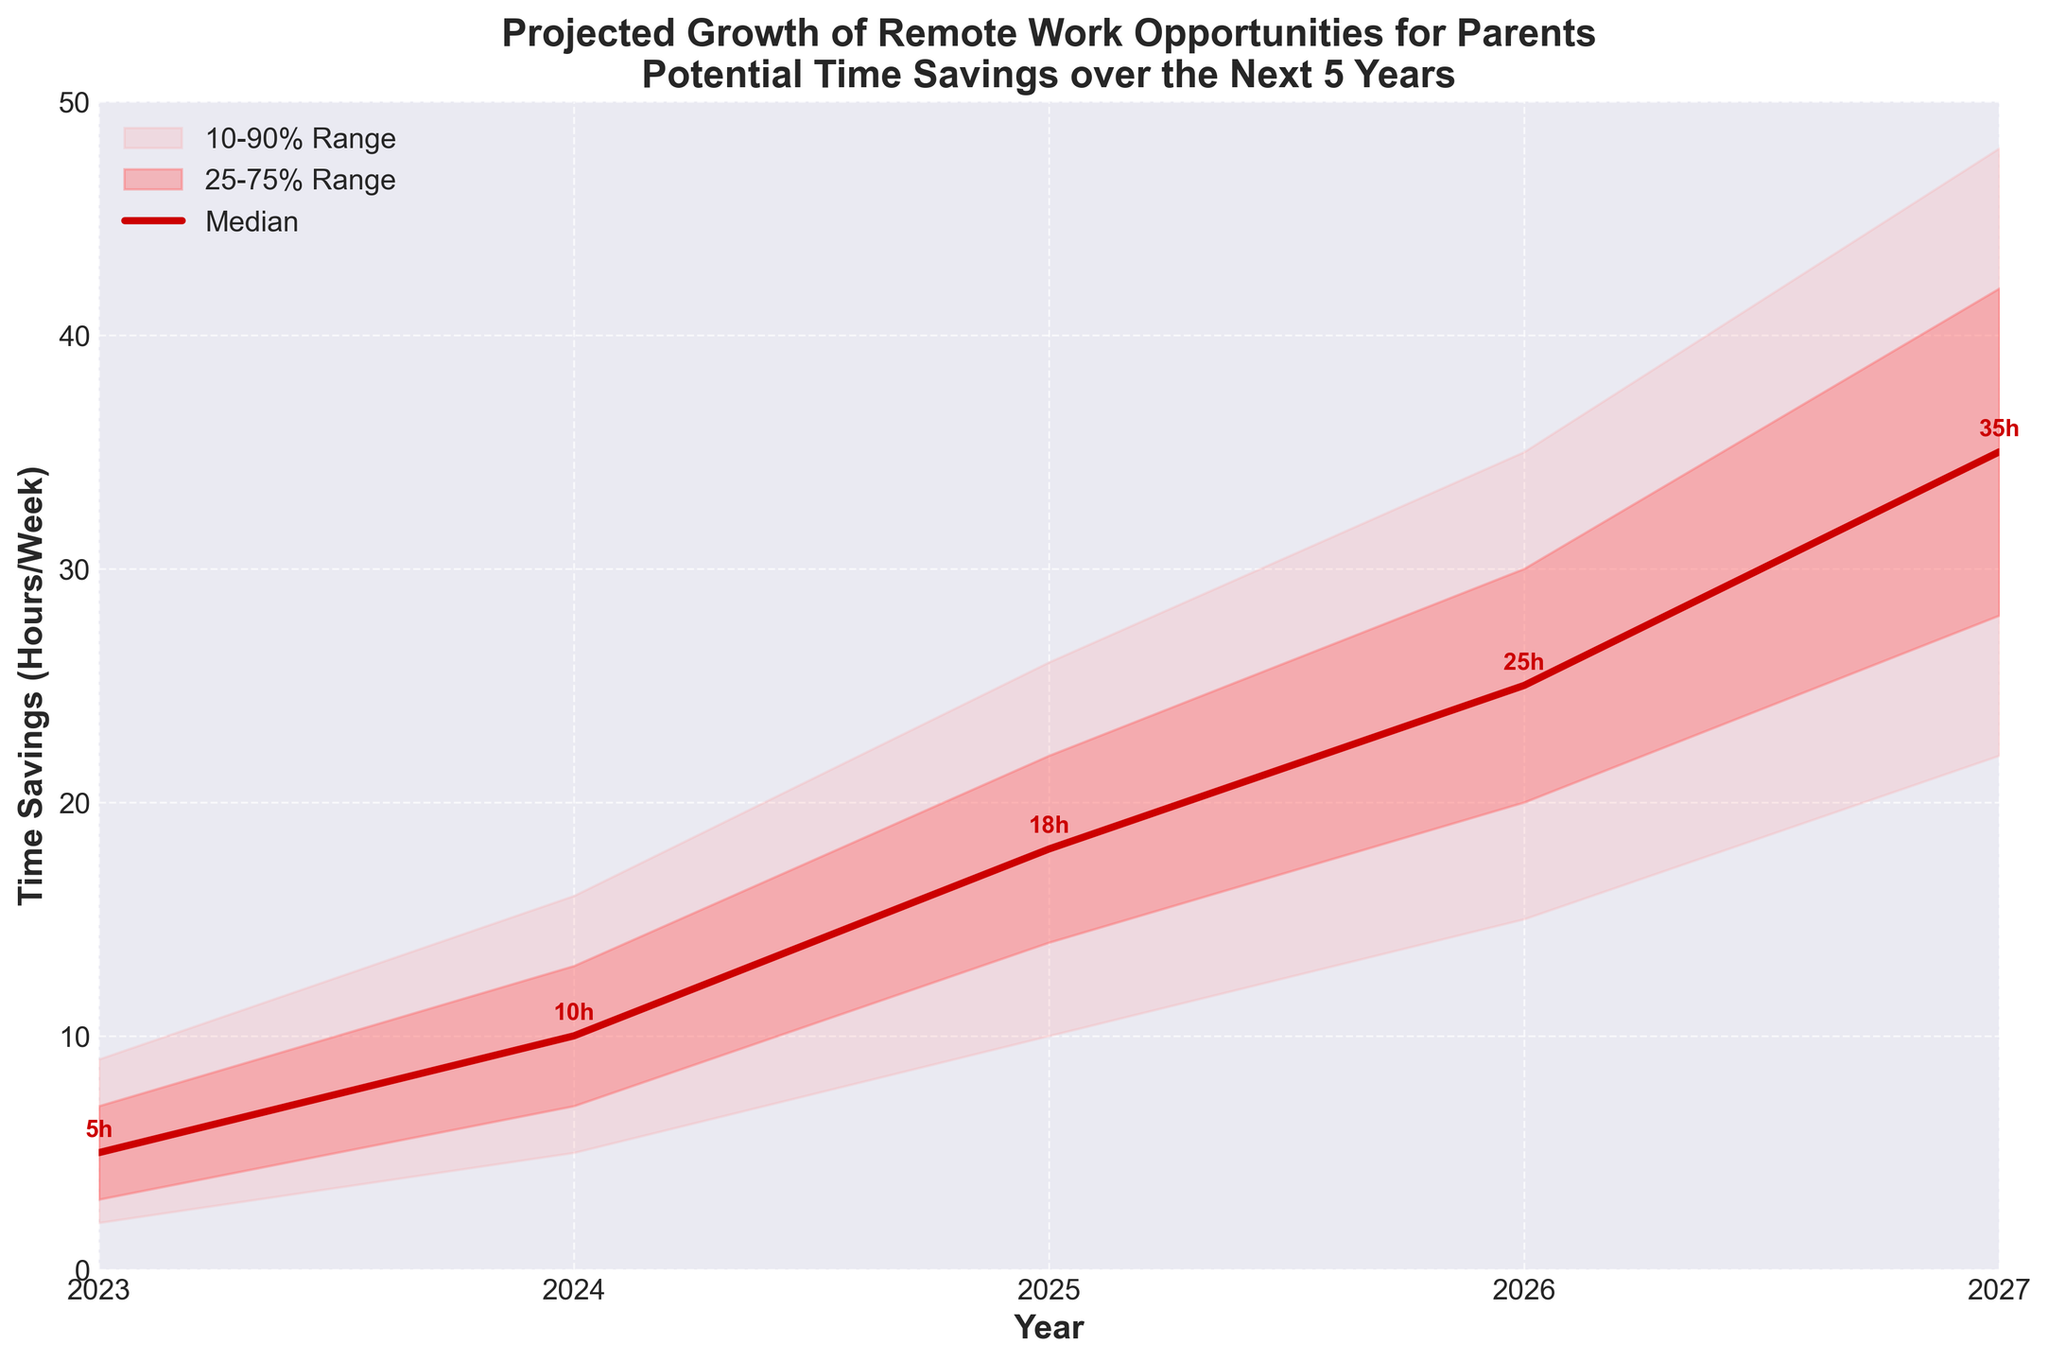what is the title of the figure? The title of the figure is located at the top. It reads: "Projected Growth of Remote Work Opportunities for Parents: Potential Time Savings over the Next 5 Years".
Answer: Projected Growth of Remote Work Opportunities for Parents: Potential Time Savings over the Next 5 Years How many years are shown in the plot? The x-axis labels the years, and they range from 2023 to 2027. Counting them, there are five years in total.
Answer: 5 What is the median projected time savings for the year 2025? The median values for each year are marked and labeled along the central line of the plot. For 2025, the median value labeled is 18 hours.
Answer: 18 hours By how many hours is the lower 10% value in 2027 different from the lower 25% value in the same year? The lower 10% value for 2027 is 22 hours, and the lower 25% value is 28 hours. The difference is calculated as 28 - 22 hours.
Answer: 6 hours What is the difference between the upper 90% and the lower 10% time savings for the year 2024? Looking at the values on the y-axis for 2024, the upper 90% is 16 hours and the lower 10% is 5 hours. The difference is calculated as 16 - 5 hours.
Answer: 11 hours Which year shows the highest median time savings, and what is this value? Among the labeled median values, the highest is for the year 2027 with a value of 35 hours.
Answer: 2027, 35 hours What is the range of potential time savings (10%-90%) in 2026? For 2026, the plot shows the lower 10% value as 15 hours and the upper 90% value as 35 hours. The range is calculated as 35 - 15 hours.
Answer: 20 hours Between which two consecutive years is the increase in median time savings the greatest? By examining the median values for consecutive years:
  - 2023 to 2024: 10 - 5 = 5 hours
  - 2024 to 2025: 18 - 10 = 8 hours
  - 2025 to 2026: 25 - 18 = 7 hours
  - 2026 to 2027: 35 - 25 = 10 hours
The greatest increase is between 2026 and 2027.
Answer: 2026 to 2027 Which range (lower 10%-upper 90% or lower 25%-upper 75%) shows a wider spread for 2024? For 2024, the 10%-90% range is from 5 to 16 hours, so 16 - 5 = 11 hours. The 25%-75% range is from 7 to 13 hours, so 13 - 7 = 6 hours. The 10%-90% range is wider.
Answer: 10%-90% How does the spread of potential savings in 2027 (10%-90%) compare to that in 2023? For 2023, the spread is 9 - 2 = 7 hours. For 2027, the spread is 48 - 22 = 26 hours. The spread in 2027 is significantly wider than in 2023.
Answer: Wider in 2027 